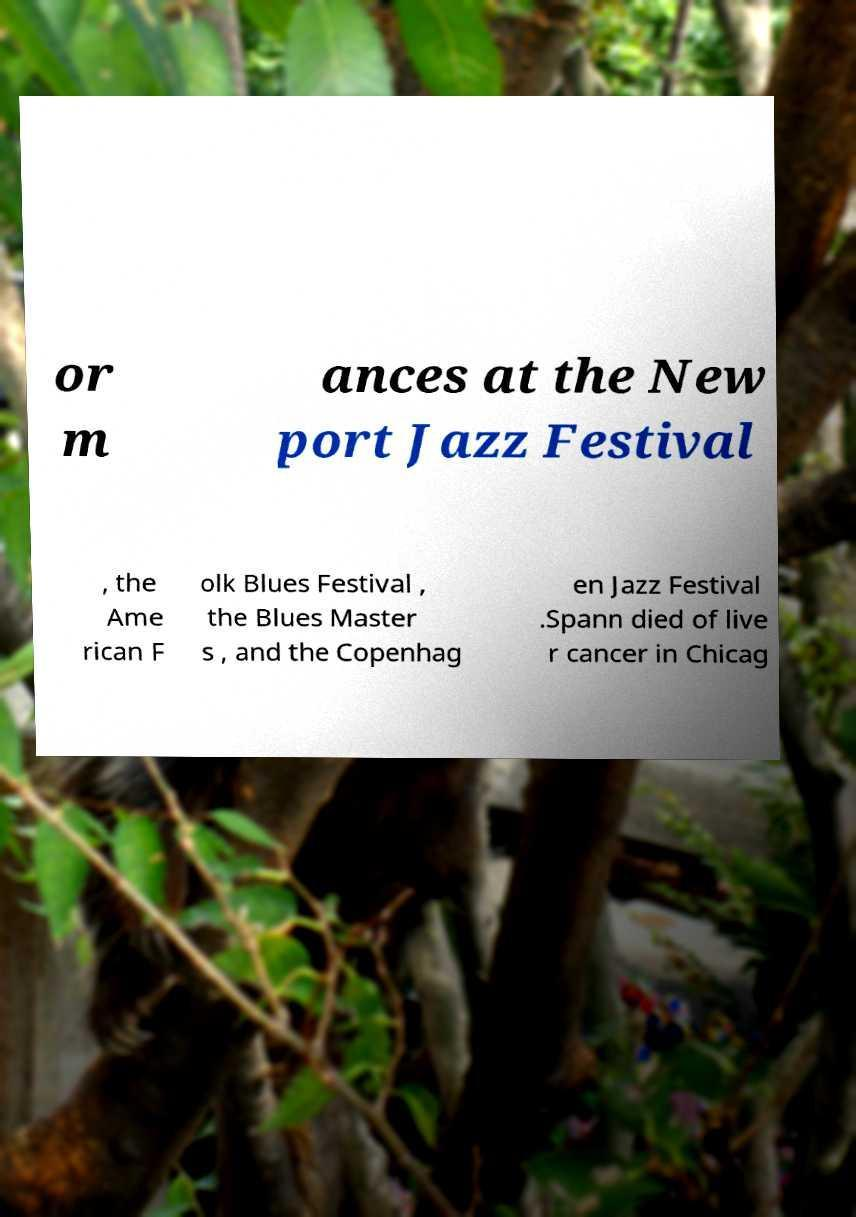Could you extract and type out the text from this image? or m ances at the New port Jazz Festival , the Ame rican F olk Blues Festival , the Blues Master s , and the Copenhag en Jazz Festival .Spann died of live r cancer in Chicag 